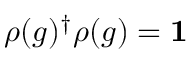<formula> <loc_0><loc_0><loc_500><loc_500>\rho ( g ) ^ { \dagger } \rho ( g ) = 1</formula> 